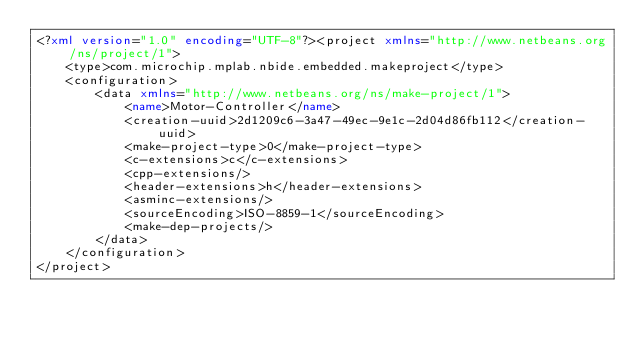Convert code to text. <code><loc_0><loc_0><loc_500><loc_500><_XML_><?xml version="1.0" encoding="UTF-8"?><project xmlns="http://www.netbeans.org/ns/project/1">
    <type>com.microchip.mplab.nbide.embedded.makeproject</type>
    <configuration>
        <data xmlns="http://www.netbeans.org/ns/make-project/1">
            <name>Motor-Controller</name>
            <creation-uuid>2d1209c6-3a47-49ec-9e1c-2d04d86fb112</creation-uuid>
            <make-project-type>0</make-project-type>
            <c-extensions>c</c-extensions>
            <cpp-extensions/>
            <header-extensions>h</header-extensions>
            <asminc-extensions/>
            <sourceEncoding>ISO-8859-1</sourceEncoding>
            <make-dep-projects/>
        </data>
    </configuration>
</project>
</code> 